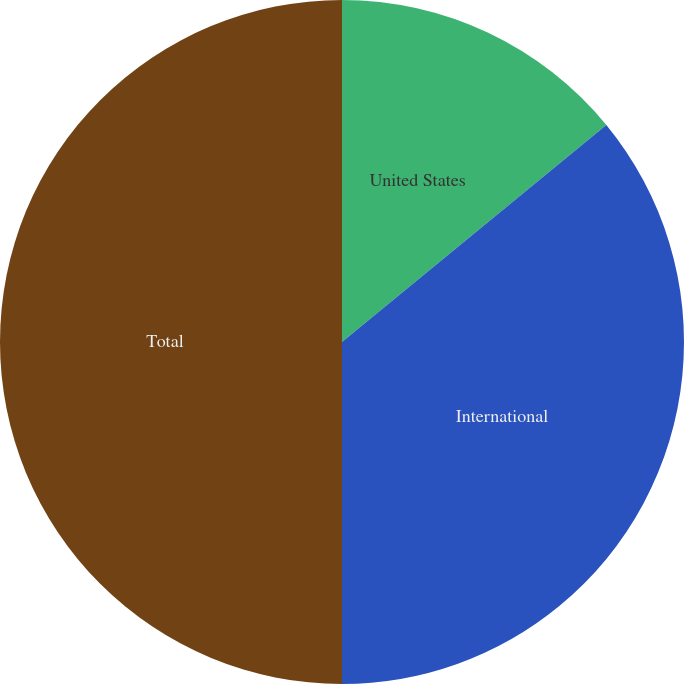<chart> <loc_0><loc_0><loc_500><loc_500><pie_chart><fcel>United States<fcel>International<fcel>Total<nl><fcel>14.06%<fcel>35.94%<fcel>50.0%<nl></chart> 